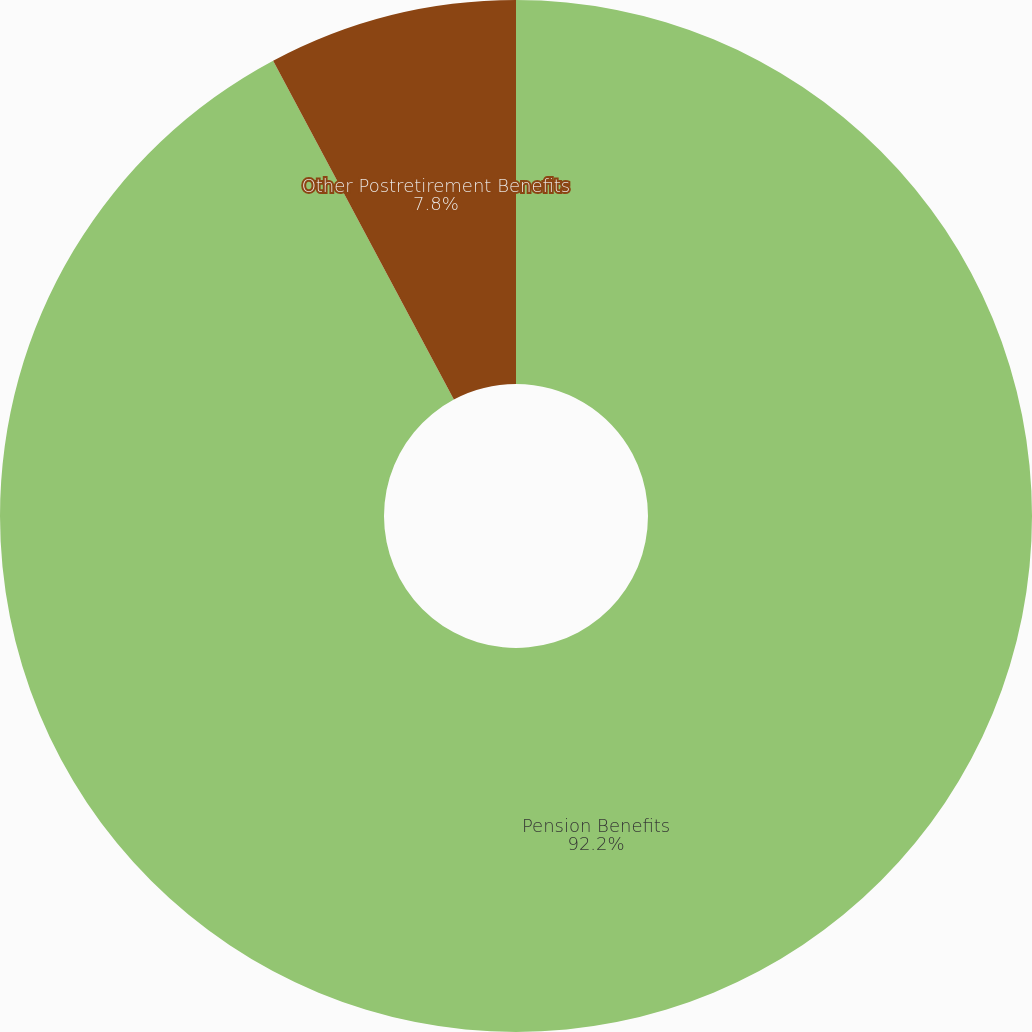Convert chart to OTSL. <chart><loc_0><loc_0><loc_500><loc_500><pie_chart><fcel>Pension Benefits<fcel>Other Postretirement Benefits<nl><fcel>92.2%<fcel>7.8%<nl></chart> 